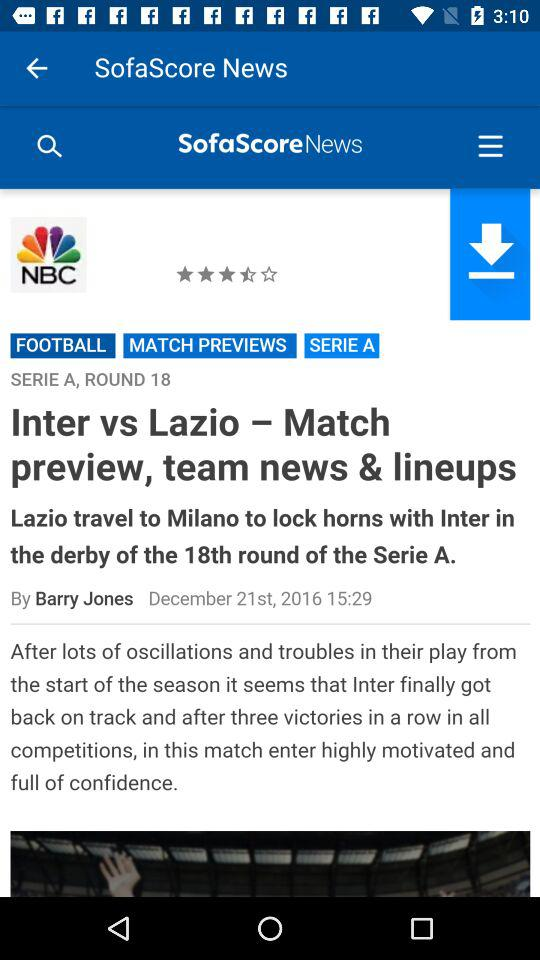What is the star rating? The star rating is 3.5. 